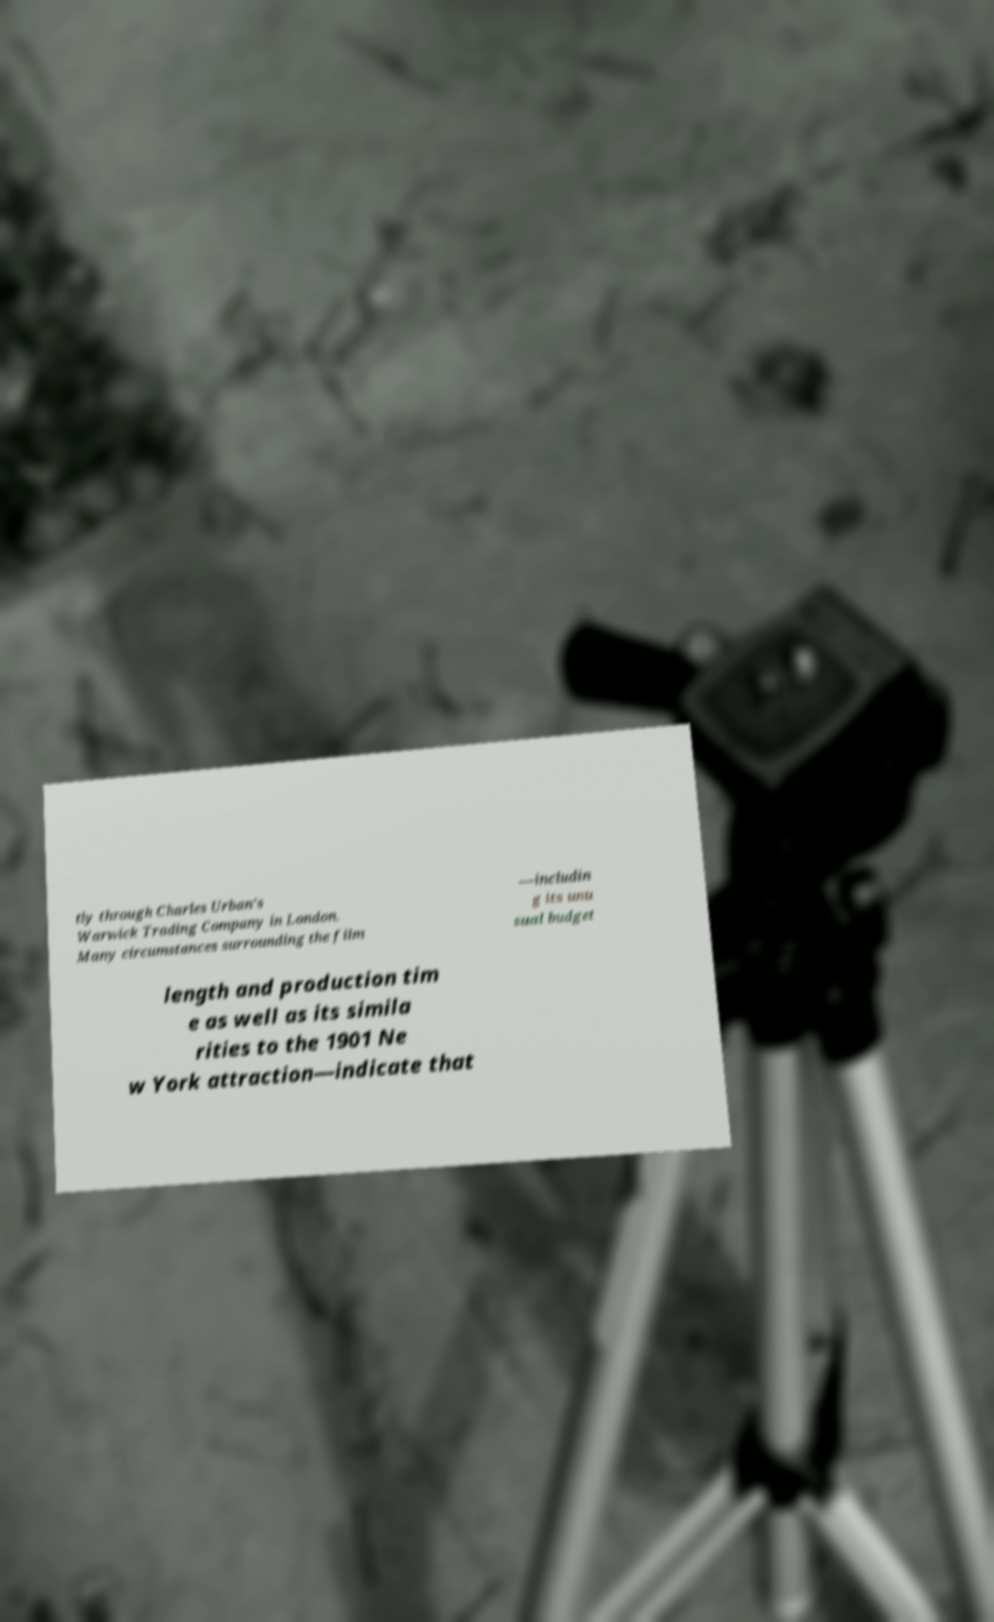Can you read and provide the text displayed in the image?This photo seems to have some interesting text. Can you extract and type it out for me? tly through Charles Urban's Warwick Trading Company in London. Many circumstances surrounding the film —includin g its unu sual budget length and production tim e as well as its simila rities to the 1901 Ne w York attraction—indicate that 